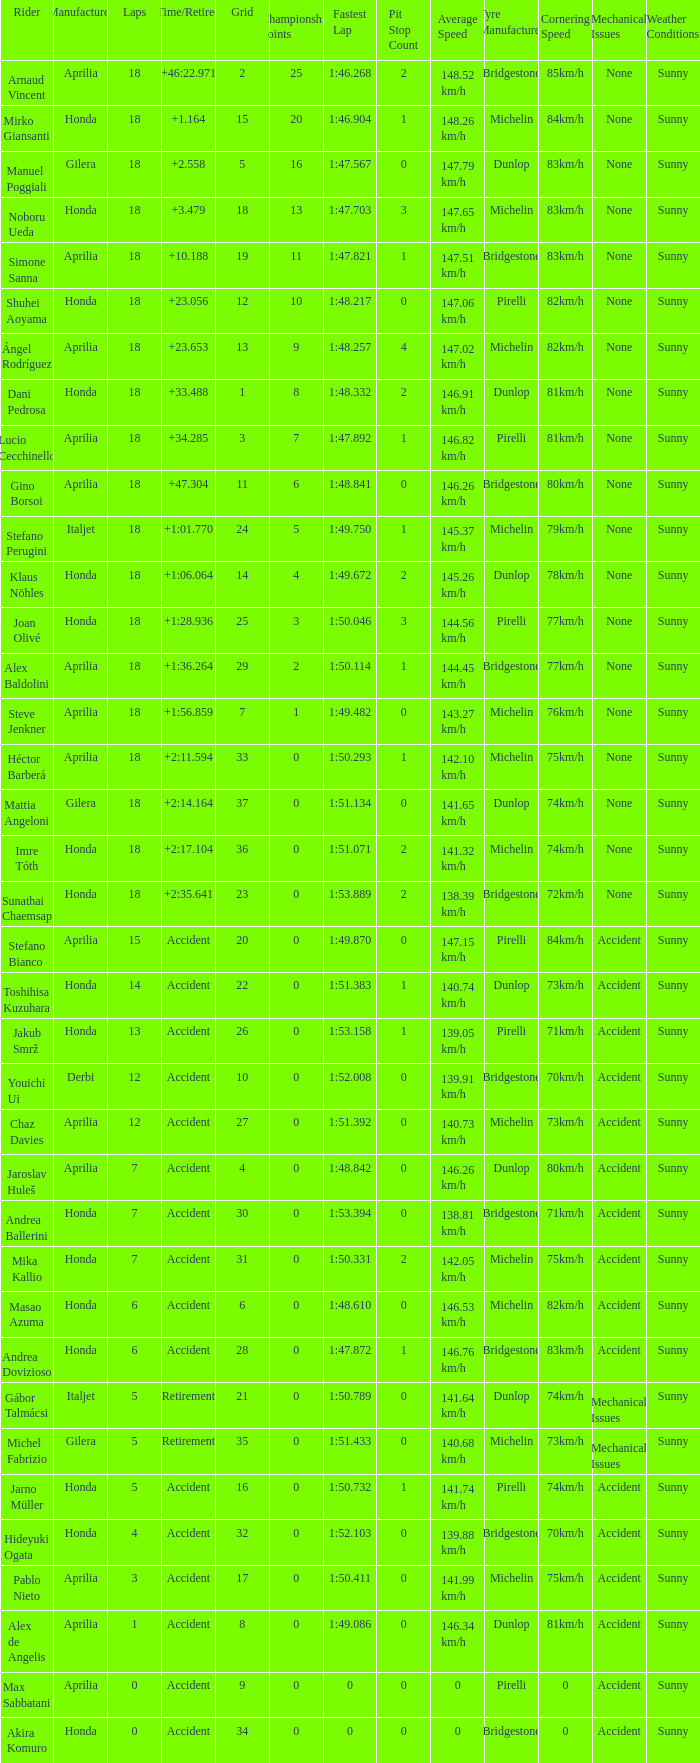What is the average number of laps with an accident time/retired, aprilia manufacturer and a grid of 27? 12.0. 